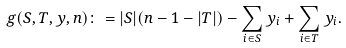<formula> <loc_0><loc_0><loc_500><loc_500>g ( S , T , y , n ) \colon = | S | ( n - 1 - | T | ) - \sum _ { i \in S } y _ { i } + \sum _ { i \in T } y _ { i } .</formula> 